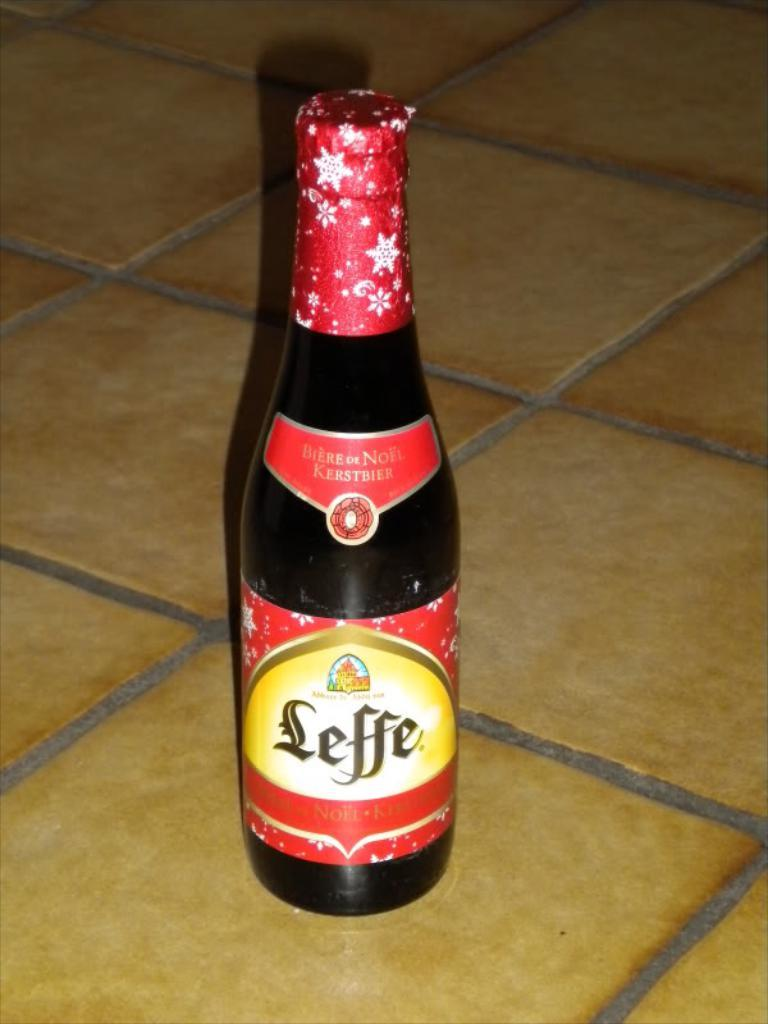<image>
Share a concise interpretation of the image provided. The Leffe beer bottle has red foil around the top with white snowflakes on it. 